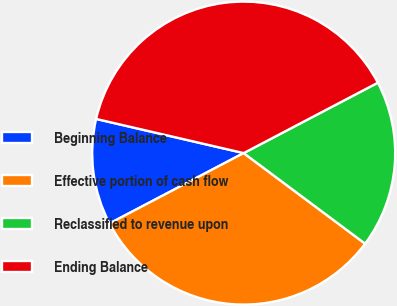<chart> <loc_0><loc_0><loc_500><loc_500><pie_chart><fcel>Beginning Balance<fcel>Effective portion of cash flow<fcel>Reclassified to revenue upon<fcel>Ending Balance<nl><fcel>11.31%<fcel>32.11%<fcel>17.89%<fcel>38.69%<nl></chart> 